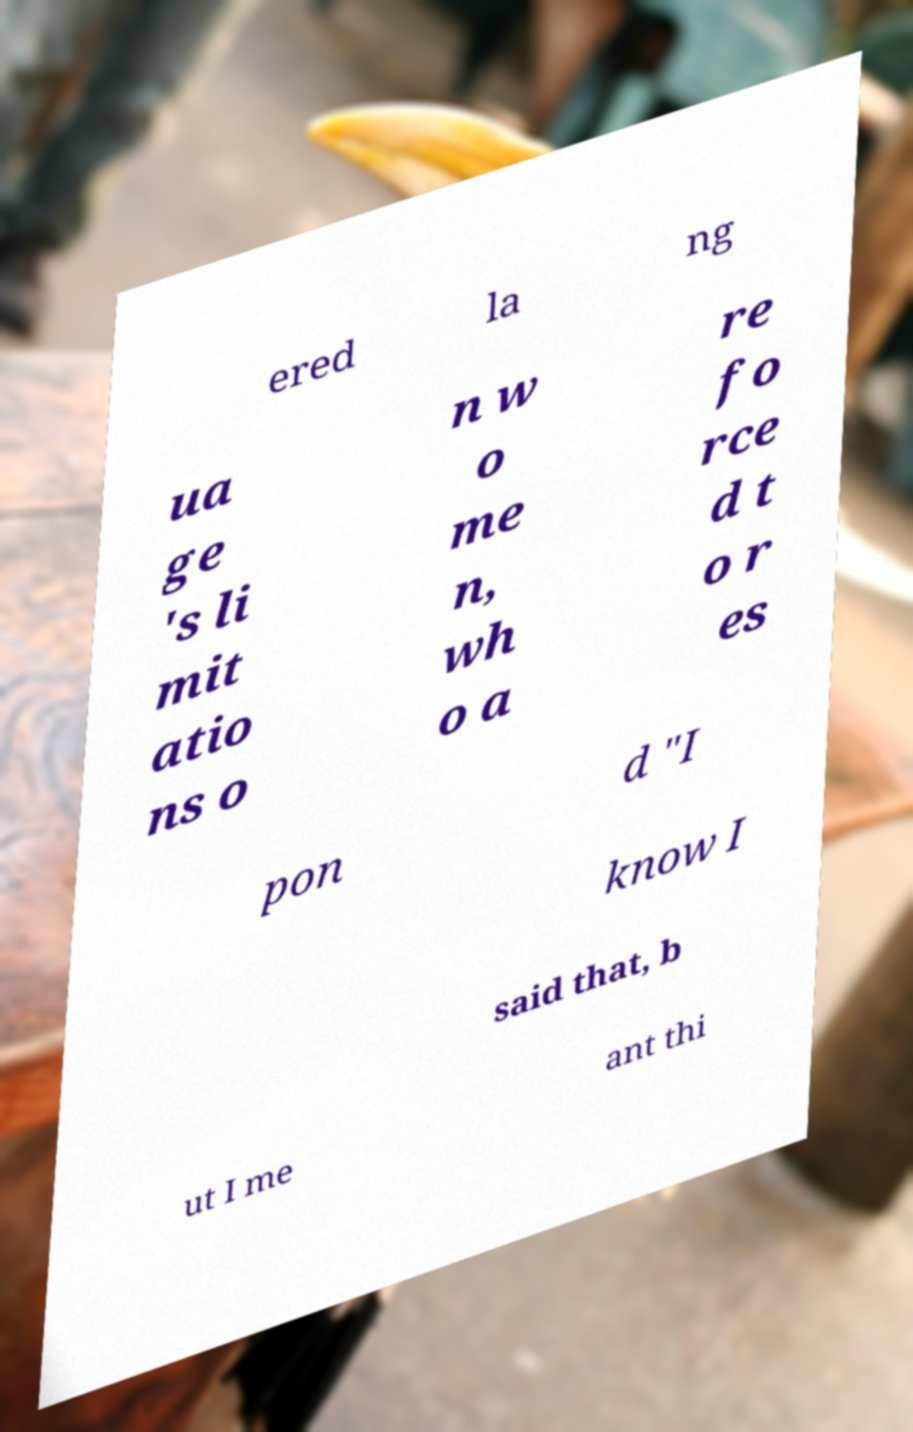For documentation purposes, I need the text within this image transcribed. Could you provide that? ered la ng ua ge 's li mit atio ns o n w o me n, wh o a re fo rce d t o r es pon d "I know I said that, b ut I me ant thi 